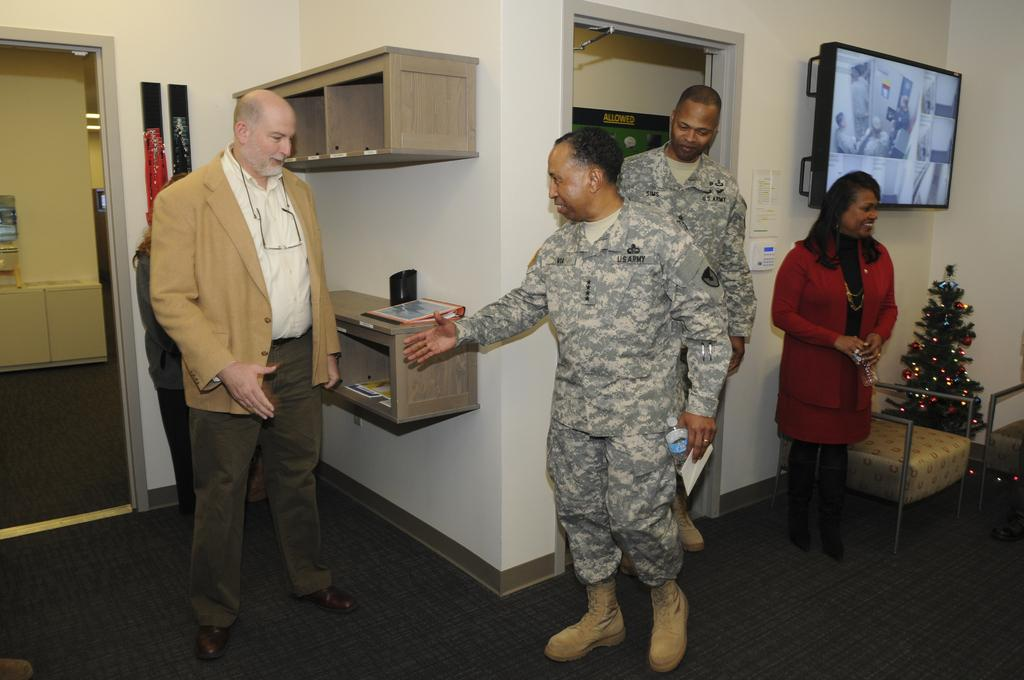How many people are present in the image? There are four people in the image. What is the main decoration in the image? There is a Christmas tree in the image. What type of furniture is visible in the image? There are chairs in the image. Can you describe the position of the desk in the image? There is a desk against a wall in the image. What type of flowers are on the desk in the image? There are no flowers present on the desk in the image. How does the monkey interact with the people in the image? There is no monkey present in the image. 